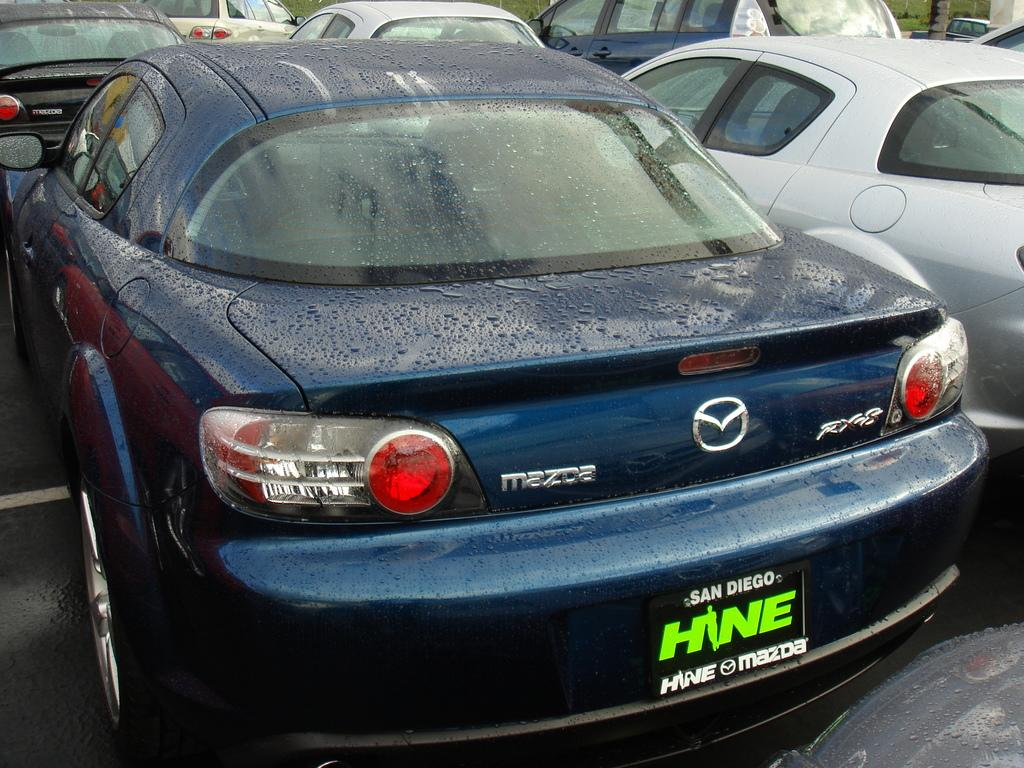What type of vehicles can be seen in the image? There are cars in the image. Is there any text present in the image? Yes, there is a board with text at the bottom of the image. What type of emotion is displayed on the cars in the image? Cars do not display emotions, so it is not possible to determine the emotion present in the image. 